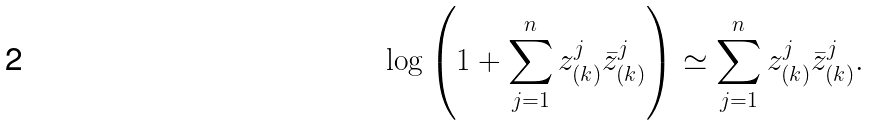Convert formula to latex. <formula><loc_0><loc_0><loc_500><loc_500>\log { \left ( 1 + \sum _ { j = 1 } ^ { n } z ^ { j } _ { ( k ) } { \bar { z } } ^ { j } _ { ( k ) } \right ) } \simeq \sum _ { j = 1 } ^ { n } z ^ { j } _ { ( k ) } { \bar { z } } ^ { j } _ { ( k ) } .</formula> 